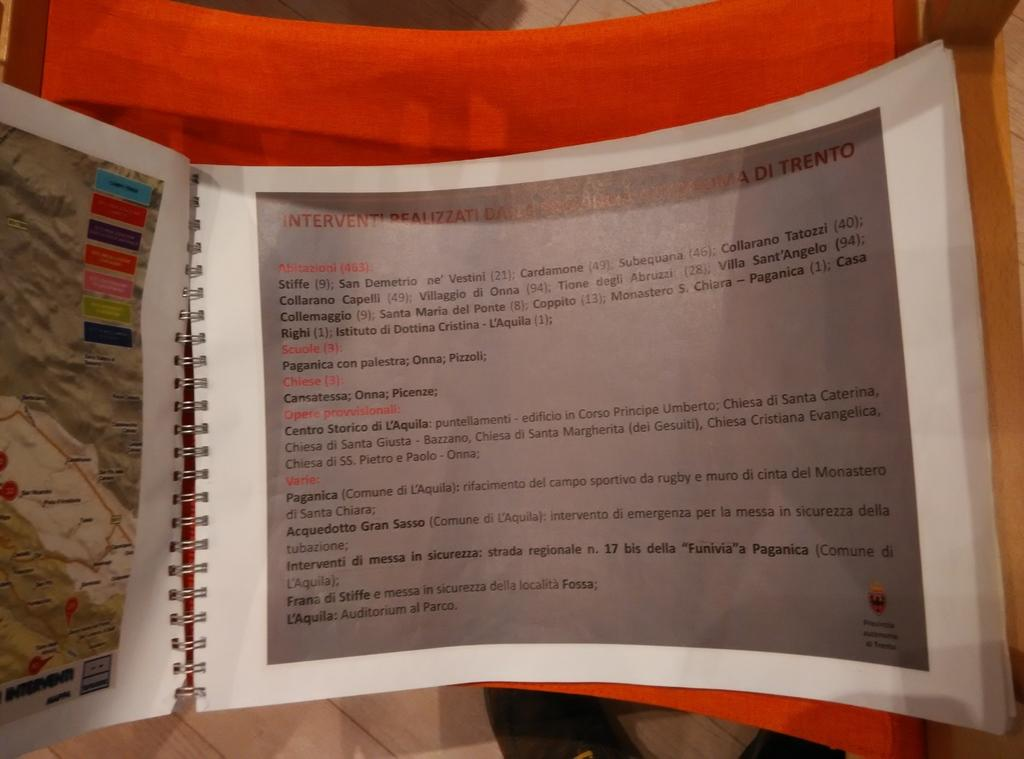Provide a one-sentence caption for the provided image. a spiral bound book is opened to a page that says Interventi at the beginnning. 